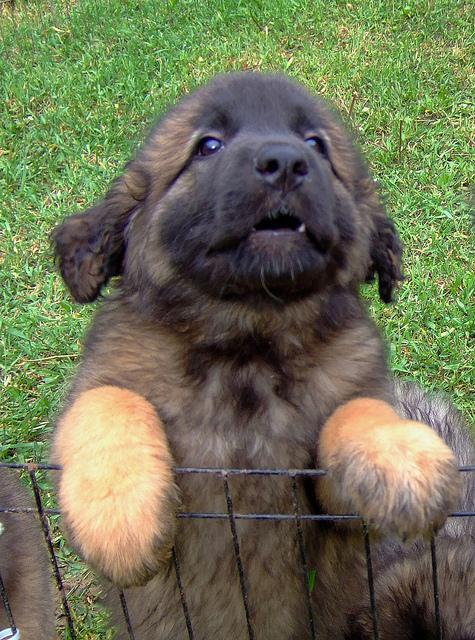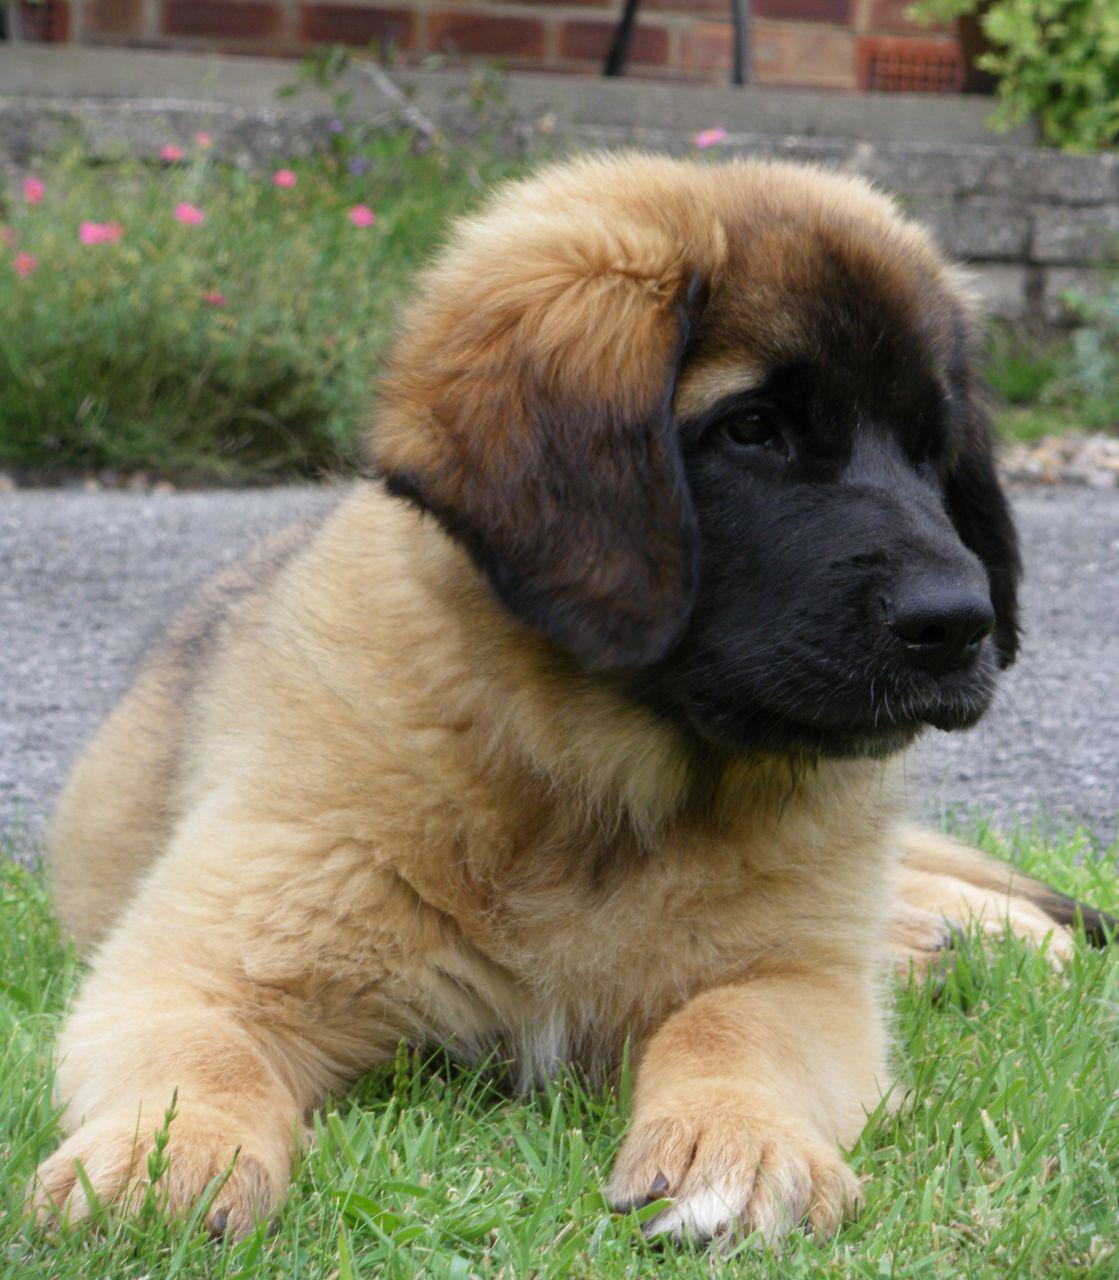The first image is the image on the left, the second image is the image on the right. Examine the images to the left and right. Is the description "The right image contains at least four dogs." accurate? Answer yes or no. No. The first image is the image on the left, the second image is the image on the right. Considering the images on both sides, is "One dog is on the back of another dog, and the image contains no more than five dogs." valid? Answer yes or no. No. 